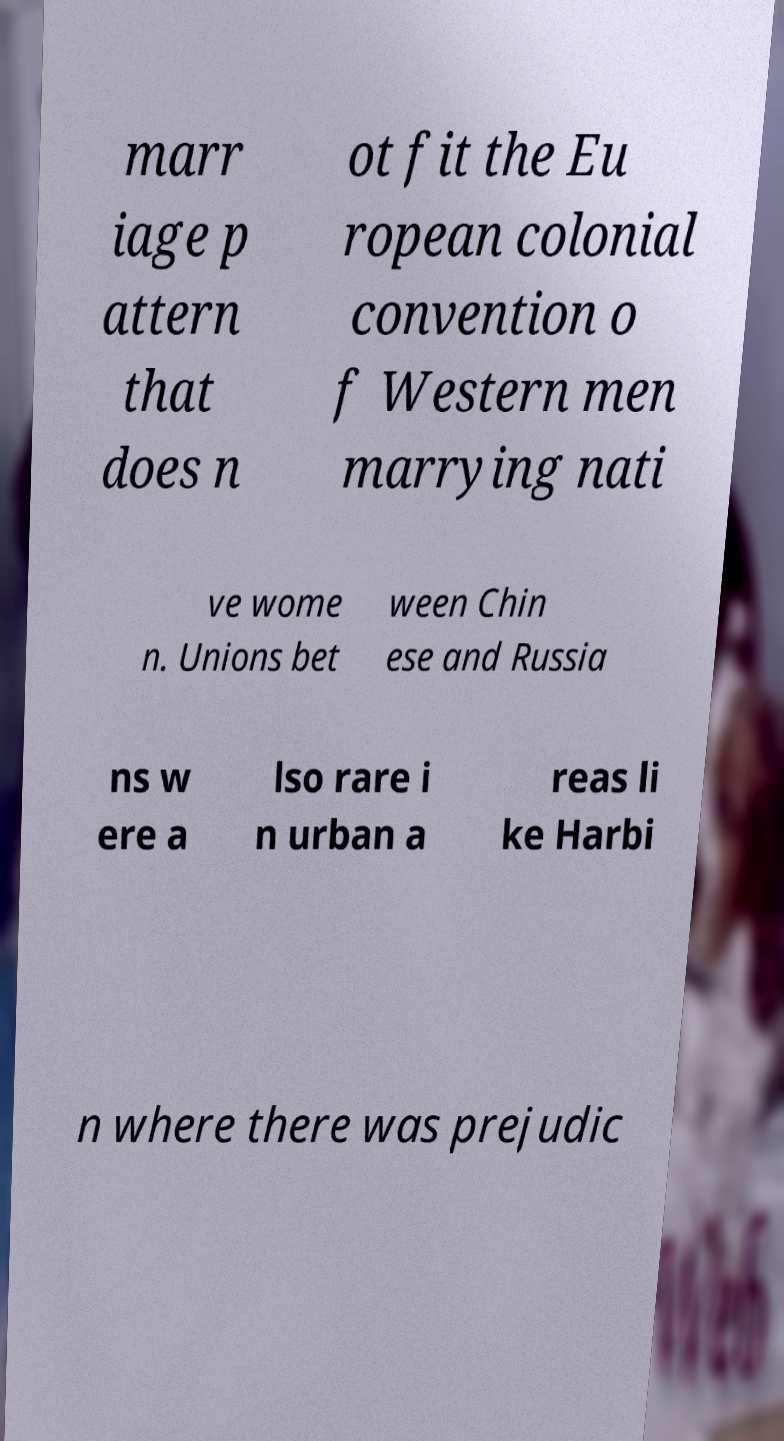Can you accurately transcribe the text from the provided image for me? marr iage p attern that does n ot fit the Eu ropean colonial convention o f Western men marrying nati ve wome n. Unions bet ween Chin ese and Russia ns w ere a lso rare i n urban a reas li ke Harbi n where there was prejudic 